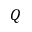Convert formula to latex. <formula><loc_0><loc_0><loc_500><loc_500>Q</formula> 